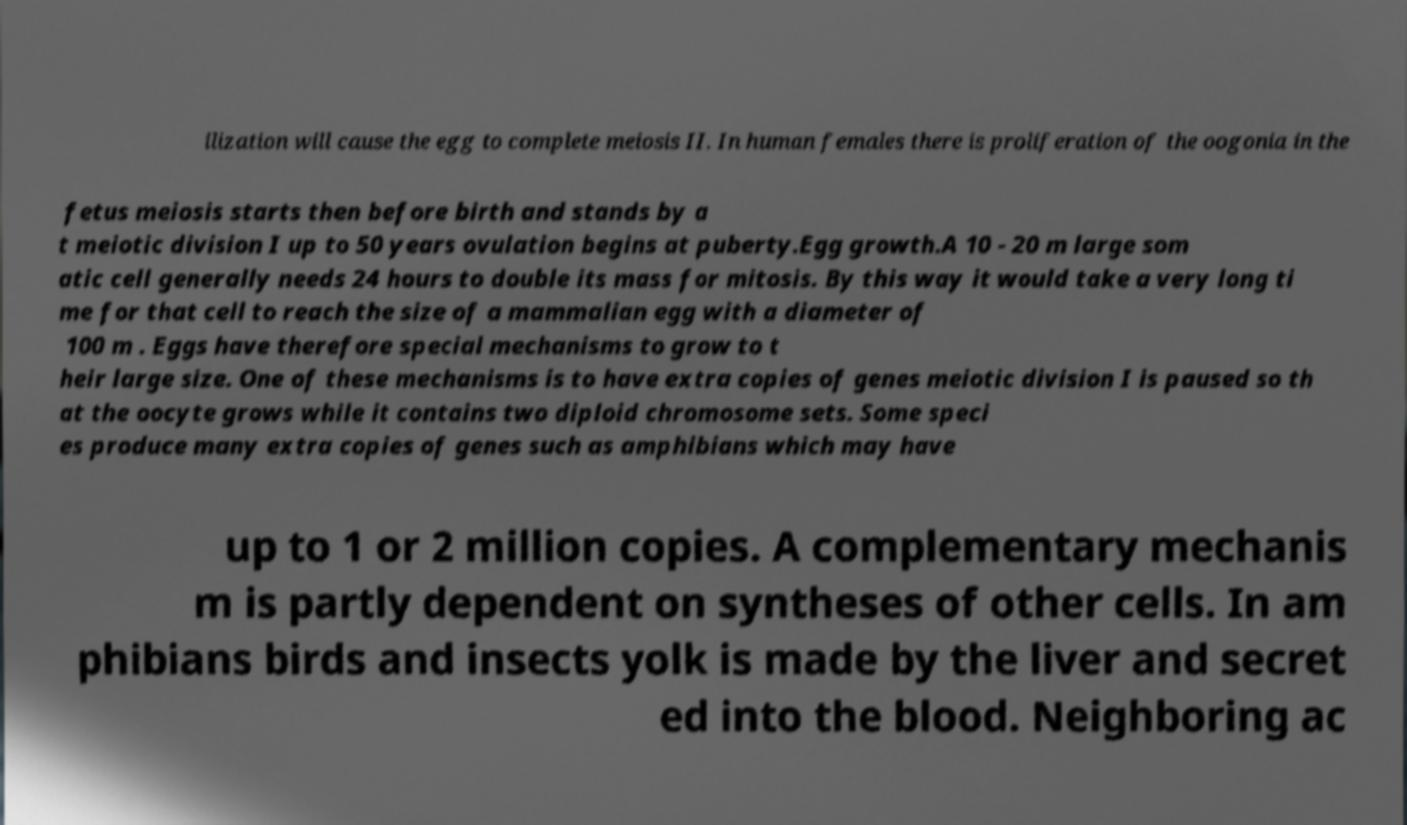Please read and relay the text visible in this image. What does it say? ilization will cause the egg to complete meiosis II. In human females there is proliferation of the oogonia in the fetus meiosis starts then before birth and stands by a t meiotic division I up to 50 years ovulation begins at puberty.Egg growth.A 10 - 20 m large som atic cell generally needs 24 hours to double its mass for mitosis. By this way it would take a very long ti me for that cell to reach the size of a mammalian egg with a diameter of 100 m . Eggs have therefore special mechanisms to grow to t heir large size. One of these mechanisms is to have extra copies of genes meiotic division I is paused so th at the oocyte grows while it contains two diploid chromosome sets. Some speci es produce many extra copies of genes such as amphibians which may have up to 1 or 2 million copies. A complementary mechanis m is partly dependent on syntheses of other cells. In am phibians birds and insects yolk is made by the liver and secret ed into the blood. Neighboring ac 